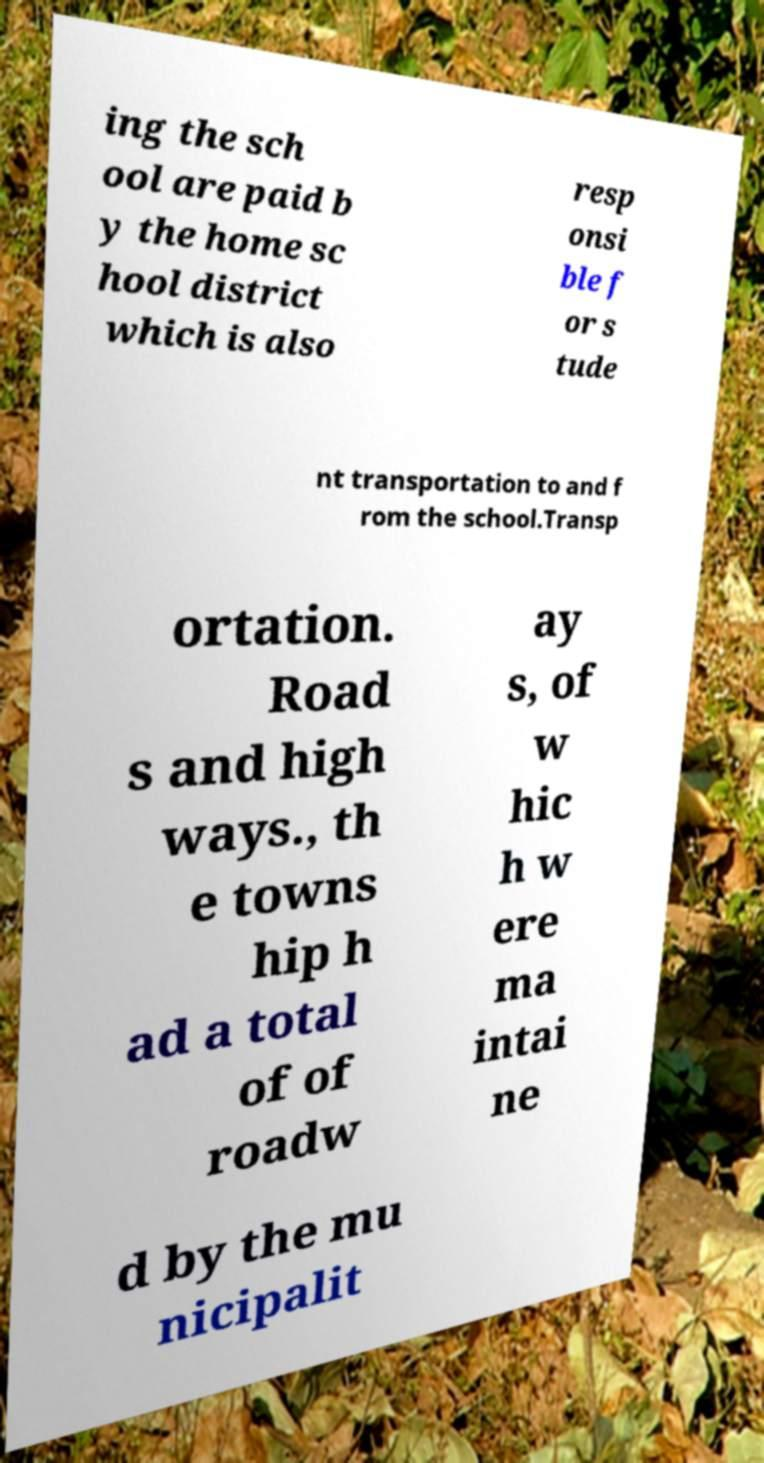For documentation purposes, I need the text within this image transcribed. Could you provide that? ing the sch ool are paid b y the home sc hool district which is also resp onsi ble f or s tude nt transportation to and f rom the school.Transp ortation. Road s and high ways., th e towns hip h ad a total of of roadw ay s, of w hic h w ere ma intai ne d by the mu nicipalit 